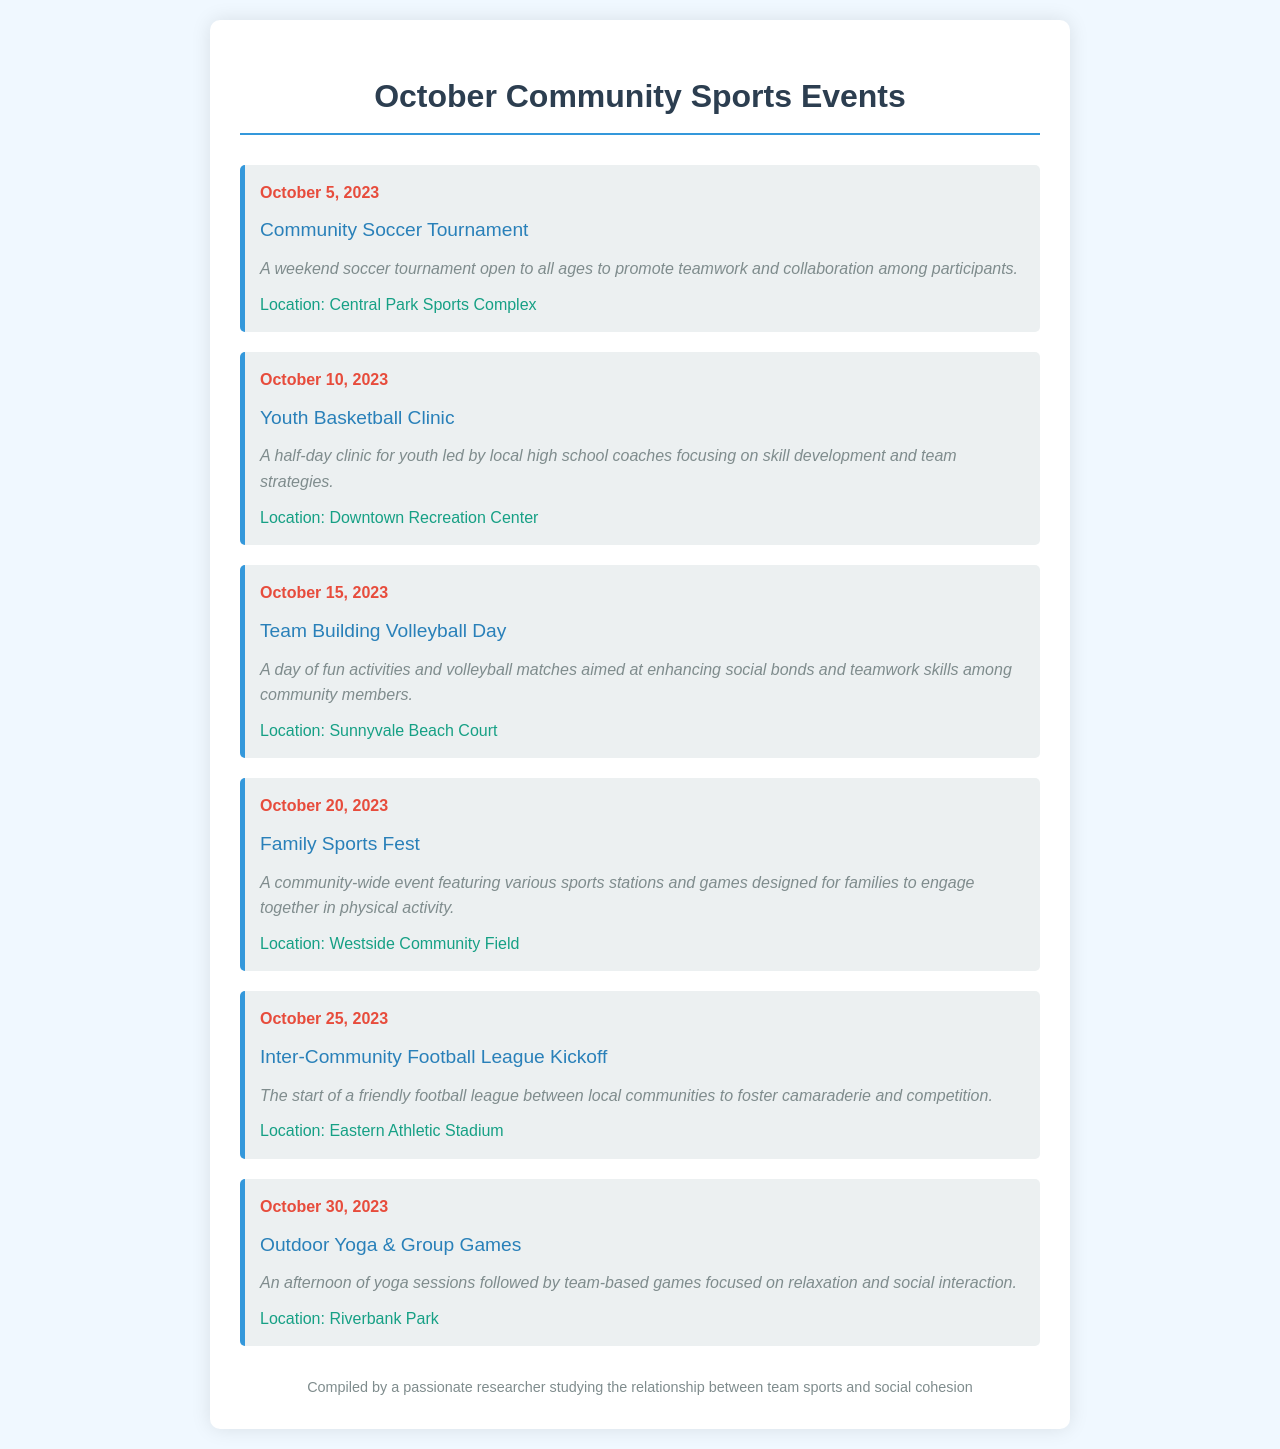What is the date of the Community Soccer Tournament? The Community Soccer Tournament is scheduled for October 5, 2023.
Answer: October 5, 2023 What is the location of the Outdoor Yoga & Group Games? The Outdoor Yoga & Group Games will be held at Riverbank Park.
Answer: Riverbank Park What type of event is scheduled for October 15, 2023? The event on October 15, 2023, is called Team Building Volleyball Day.
Answer: Team Building Volleyball Day How many sports events are listed for October? There are a total of six events listed for October.
Answer: Six What is the main focus of the Family Sports Fest? The main focus of the Family Sports Fest is for families to engage together in physical activity.
Answer: Engagement in physical activity What is the purpose of the Inter-Community Football League Kickoff? The purpose is to foster camaraderie and competition among local communities.
Answer: Camaraderie and competition Who compiled the document? The document was compiled by a passionate researcher studying the relationship between team sports and social cohesion.
Answer: A passionate researcher What is the description of the Youth Basketball Clinic? The Youth Basketball Clinic is described as a half-day clinic for youth focusing on skill development and team strategies.
Answer: Skill development and team strategies 